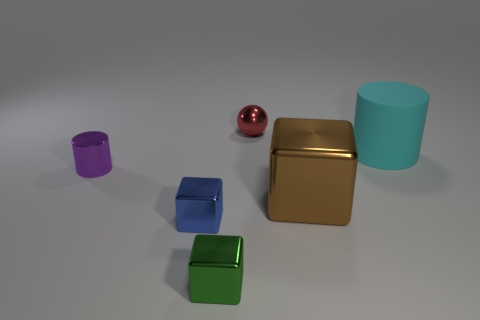Pretend these objects were characters in a story. What kind of traits might the red sphere have compared to the gold cuboid? The red sphere might have a bubbly and dynamic personality, symbolizing energy and motion, whereas the gold cuboid could represent stability, strength, and a methodical character. 